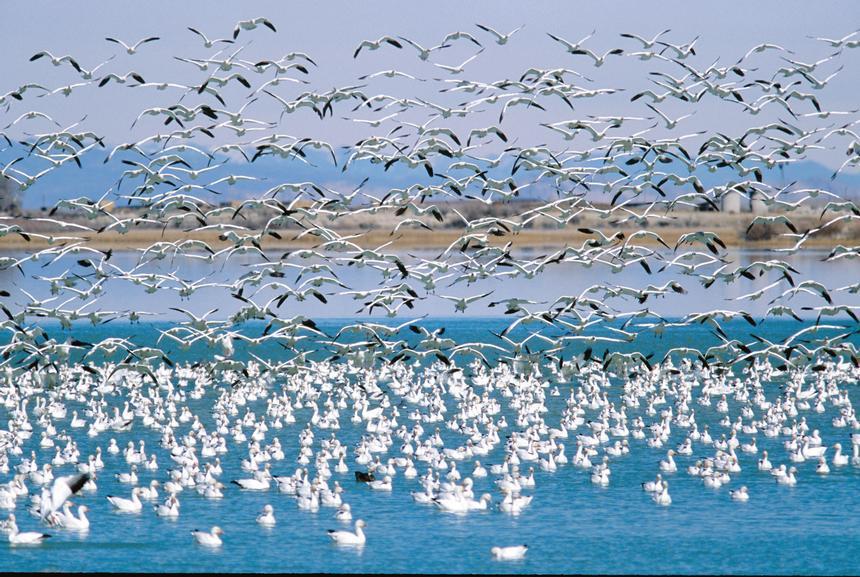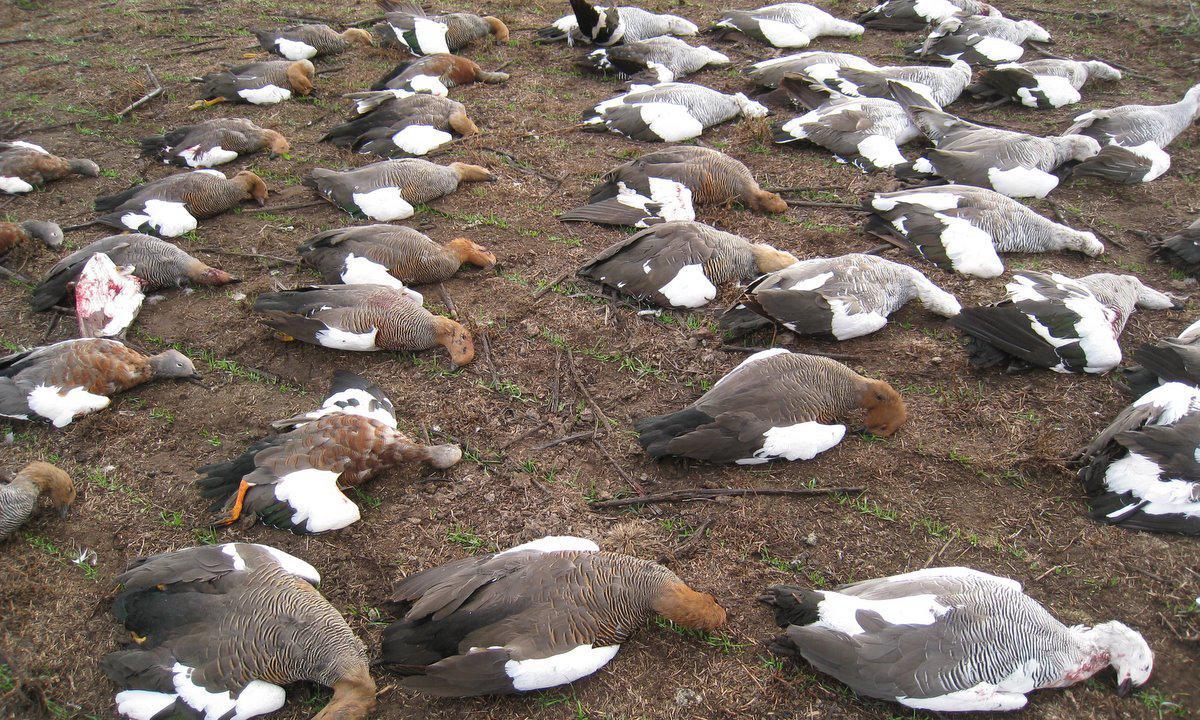The first image is the image on the left, the second image is the image on the right. Analyze the images presented: Is the assertion "All of the birds are in the water in the image on the right." valid? Answer yes or no. No. 